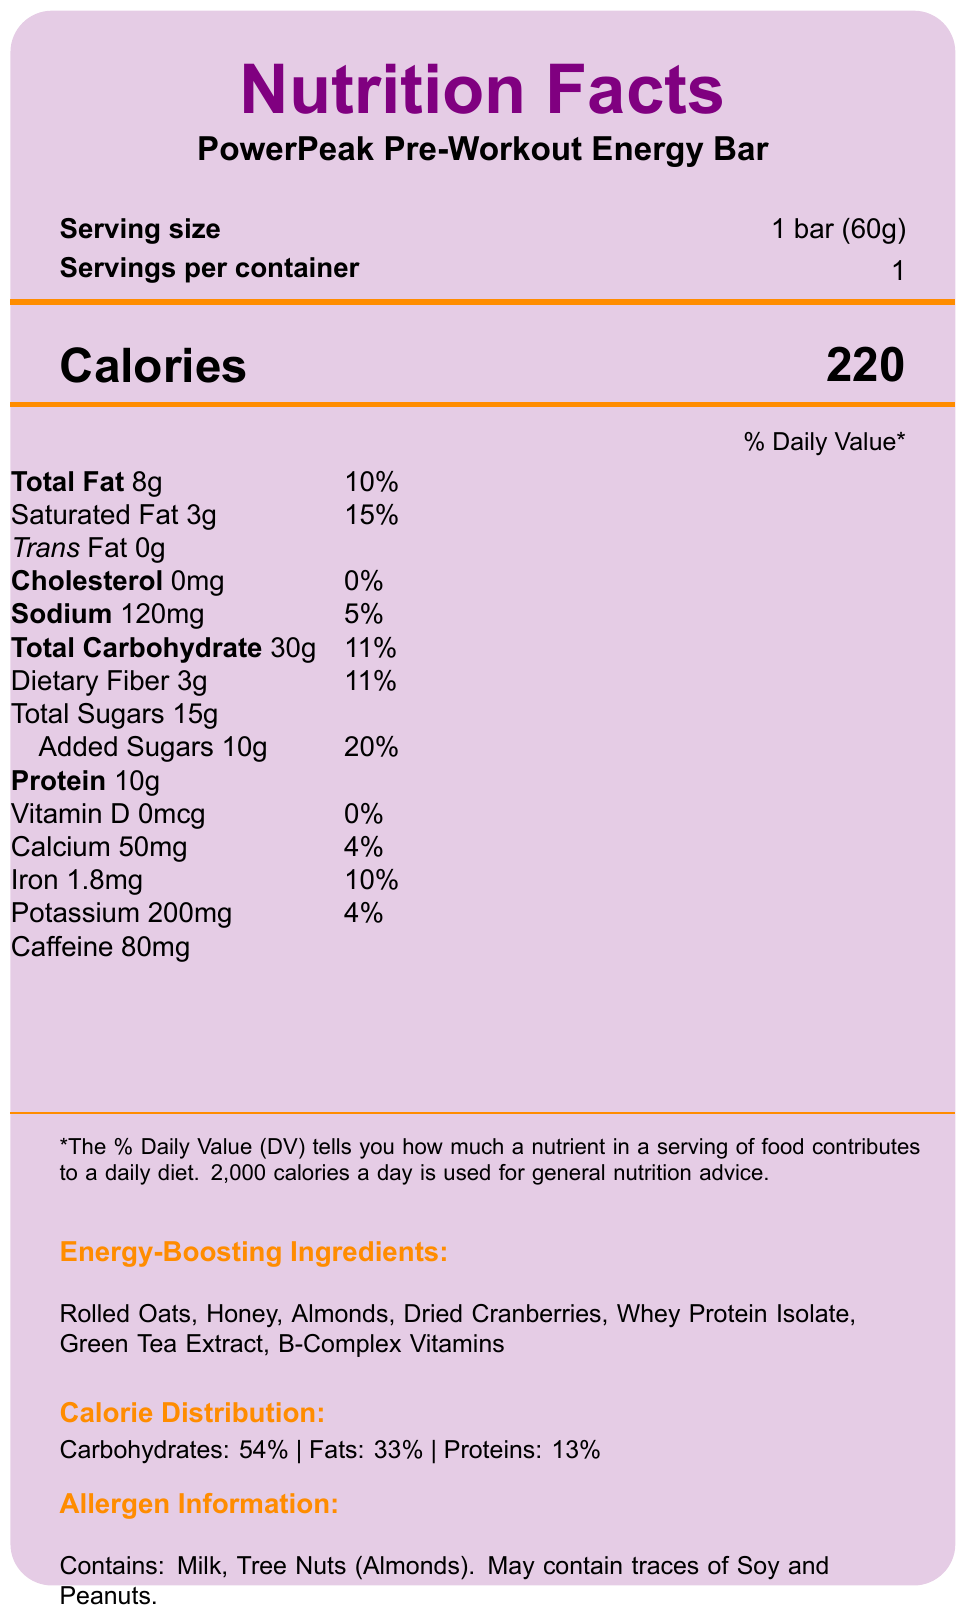what is the serving size of the PowerPeak Pre-Workout Energy Bar? The serving size is explicitly stated as "1 bar (60g)" in the serving information section of the document.
Answer: 1 bar (60g) How many calories are in one bar of the PowerPeak Pre-Workout Energy Bar? The calories are listed as "220" right under the title "Calories".
Answer: 220 What percentage of the daily value for total carbohydrates is in one bar? The percentage daily value for total carbohydrates is noted as "11%" next to "Total Carbohydrate".
Answer: 11% Which energy-boosting ingredient in the bar is a natural source of quick-acting sugars? Under the "Energy-Boosting Ingredients" section, Honey is described as the ingredient providing "Natural source of quick-acting sugars for immediate energy".
Answer: Honey what is the amount of protein in one bar of the PowerPeak Pre-Workout Energy Bar? The protein content is listed as "10g" in the nutrient table.
Answer: 10g Which component has the highest percentage of calorie distribution? A. Fats B. Carbohydrates C. Proteins The calorie distribution states Carbohydrates: 54%, which is higher than Fats: 33% and Proteins: 13%.
Answer: B What is the main function of the B-Complex Vitamins in the energy bar? A. Provide antioxidants B. Add flavor C. Support energy metabolism and cognitive function D. Boost protein content The document lists B-Complex Vitamins under "Energy-Boosting Ingredients" with the benefit "Essential for energy metabolism and cognitive function".
Answer: C Does the PowerPeak Pre-Workout Energy Bar contain any caffeine? The ingredient list explicitly mentions "Caffeine 80mg".
Answer: Yes Summarize the main purpose of the PowerPeak Pre-Workout Energy Bar. The detailed description of the bar's ingredients, their benefits, and the recommended use together highlight the bar's purpose of providing sustained energy and enhancing workout performance.
Answer: The PowerPeak Pre-Workout Energy Bar is designed to provide a balanced mix of quick and sustained energy sources. It combines complex carbohydrates, proteins, and healthy fats to maintain steady energy levels during a workout. The bar also contains caffeine for a moderate energy boost and B-complex vitamins for efficient energy metabolism. Can this document tell us where to buy the PowerPeak Pre-Workout Energy Bar? The document provides detailed nutritional and consumption information but does not mention where or how to purchase the bar.
Answer: Cannot be determined 